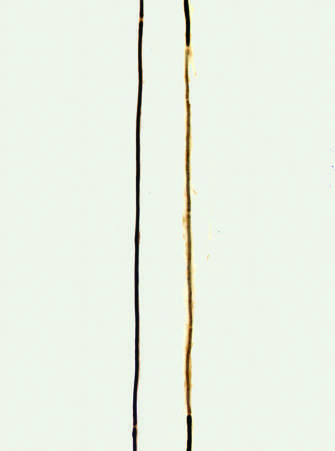do fiber preparations allow for examination of individual axons of peripheral nerves?
Answer the question using a single word or phrase. Yes 